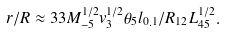Convert formula to latex. <formula><loc_0><loc_0><loc_500><loc_500>r / R \approx 3 3 M _ { - 5 } ^ { 1 / 2 } v _ { 3 } ^ { 1 / 2 } \theta _ { 5 } l _ { 0 . 1 } / R _ { 1 2 } L _ { 4 5 } ^ { 1 / 2 } .</formula> 